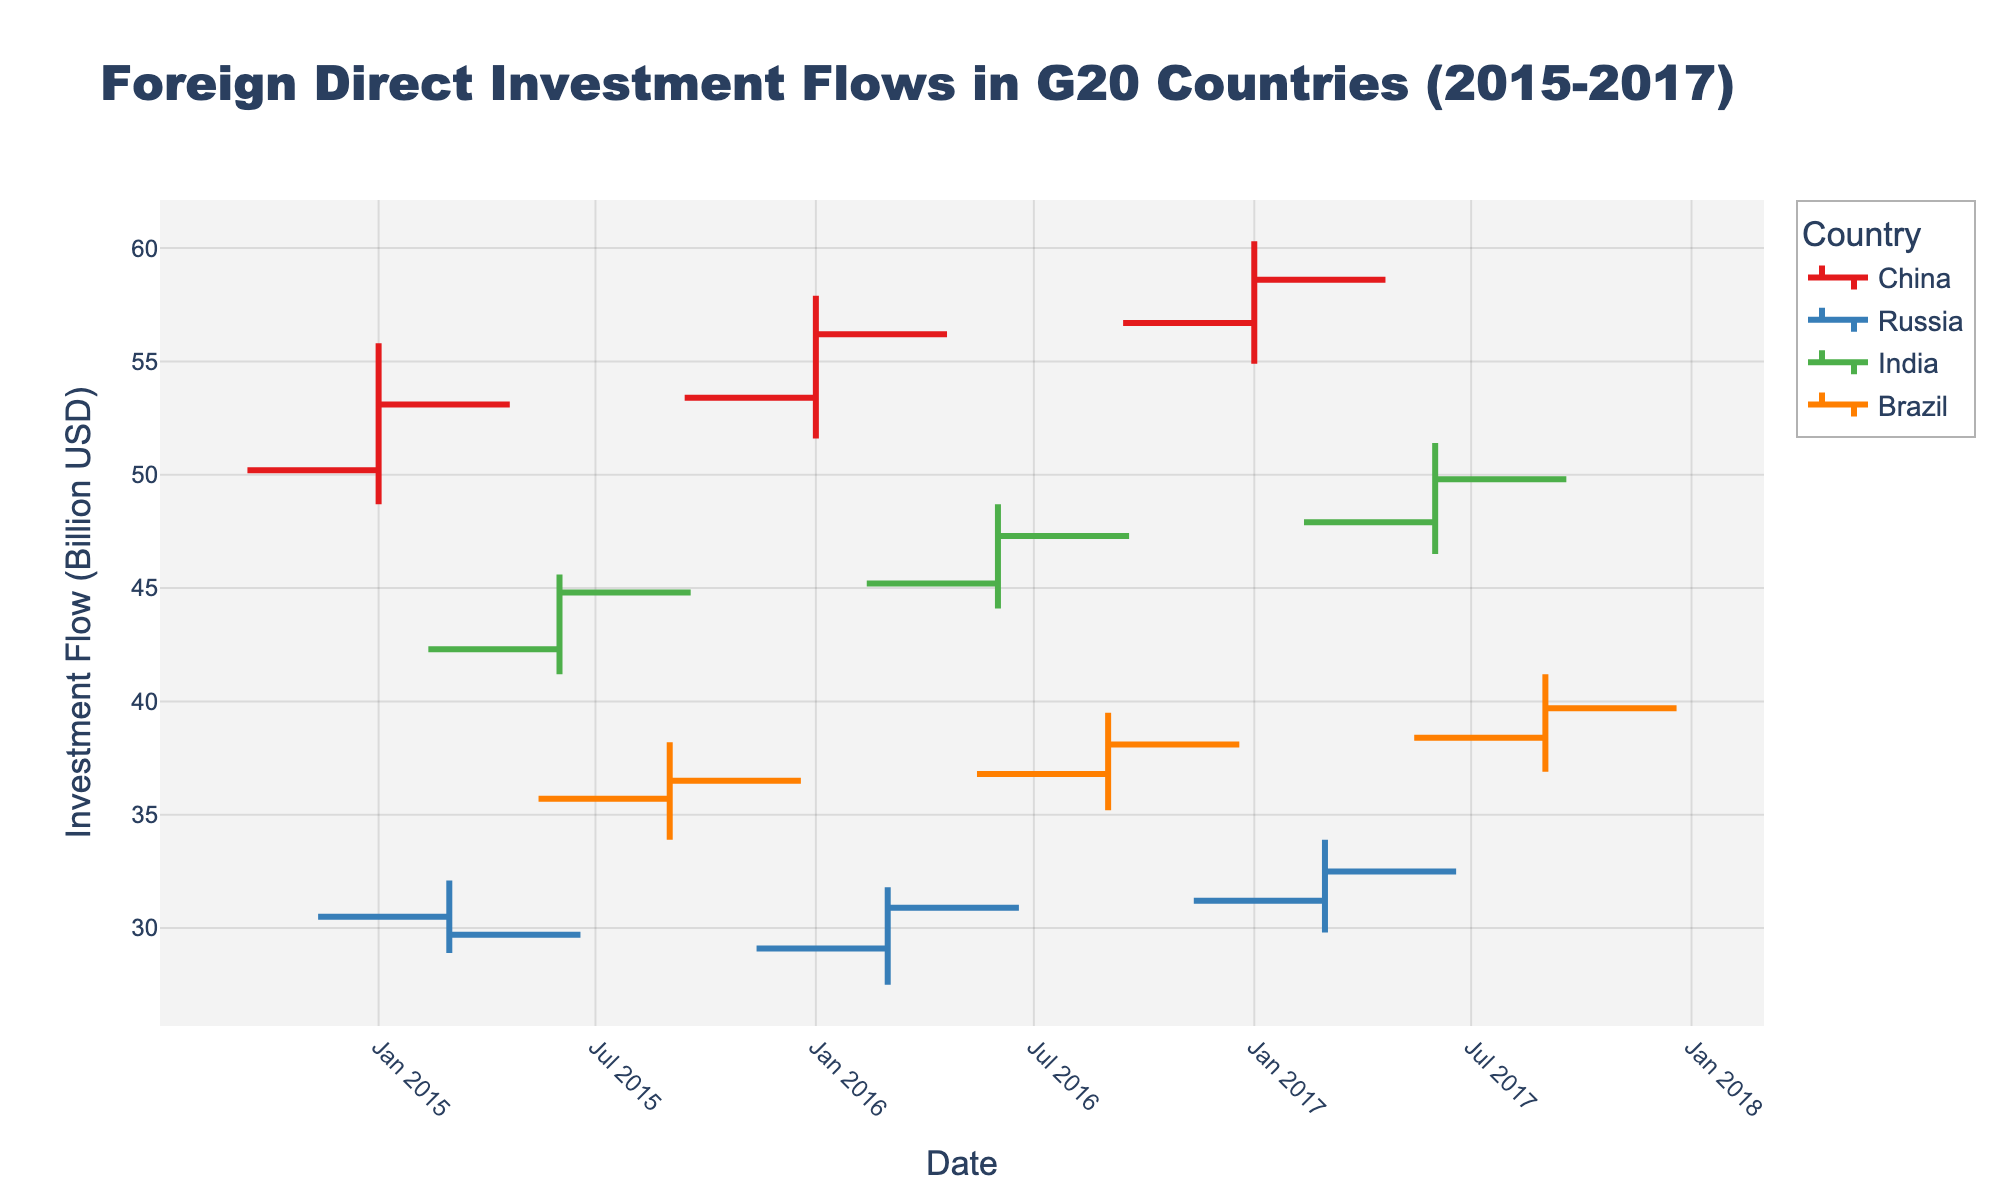Which country shows the highest high value in 2017? To determine this, look at the high values for China, Russia, India, and Brazil in 2017 and compare them. China has the highest high value of 60.3 in January 2017.
Answer: China Which country experienced the lowest close value across the entire period? Review the close values for all countries and find the minimum. The lowest close value is 29.7 for Russia in January 2015.
Answer: Russia What is the average open value for India across these periods? Sum the open values for India (42.3, 45.2, 47.9) and divide by the number of points (3). (42.3 + 45.2 + 47.9) / 3 = 45.13.
Answer: 45.13 What is the range (high - low) for Brazil in September 2017? Subtract the low value from the high value for Brazil in September 2017. The high is 41.2 and the low is 36.9. 41.2 - 36.9 = 4.3.
Answer: 4.3 Which country has the most consistent high values over the periods? Identify the country with the most stable high values by examining deviations from the average of each country’s high values. China (55.8, 57.9, 60.3) shows smaller deviations compared to others.
Answer: China From 2015 to 2017, which country made the largest increase in close value? Subtract the close value at the start of the period from the close value at the end. For China: 58.6 - 53.1 = 5.5, Russia: 32.5 - 29.7 = 2.8, India: 49.8 - 44.8 = 5.0, Brazil: 39.7 - 36.5 = 3.2. China shows the largest increase.
Answer: China Which quarter in 2016 had the highest open value for any country? Look at the open values for all countries in 2016 and identify the highest. For China in Q1: 53.4, Q2: 45.2, Q3: 36.8. The highest is China in Q1.
Answer: Q1 2016 Did any country have the same open and close value in the same period? Compare open and close values for each country in each period. No open and close values are the same for any given country in the provided dataset.
Answer: No What is the median close value for Russia throughout the periods provided? Arrange Russia’s close values in ascending order (29.7, 30.9, 32.5) and find the middle value. The median close value is 30.9.
Answer: 30.9 